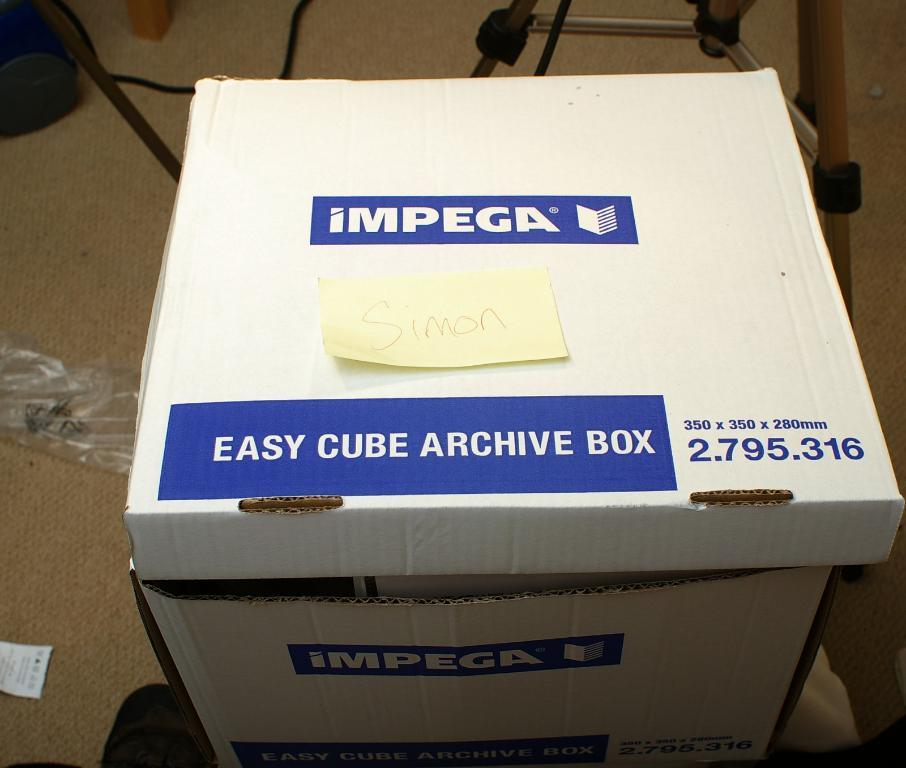<image>
Write a terse but informative summary of the picture. a box that has easy cube archive on it 